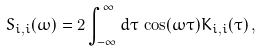<formula> <loc_0><loc_0><loc_500><loc_500>S _ { i , i } ( \omega ) = 2 \int _ { - \infty } ^ { \infty } d \tau \, \cos ( \omega \tau ) K _ { i , i } ( \tau ) \, ,</formula> 